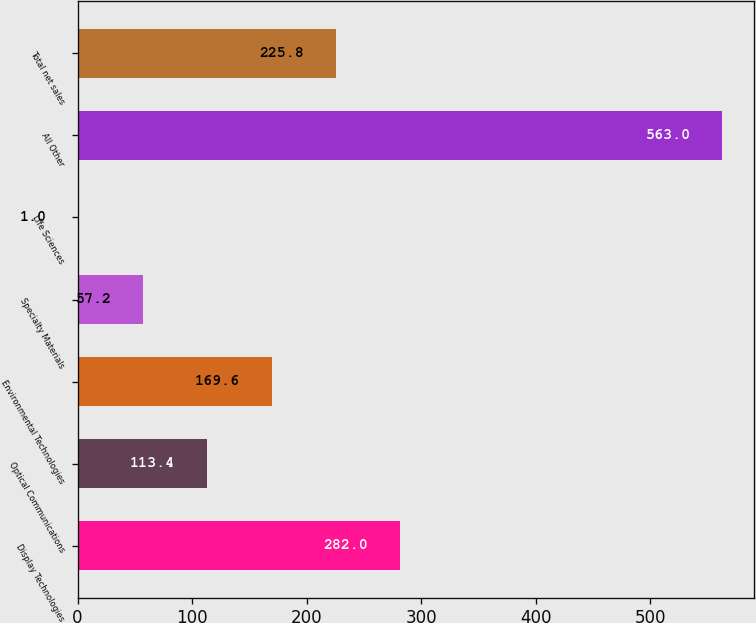Convert chart to OTSL. <chart><loc_0><loc_0><loc_500><loc_500><bar_chart><fcel>Display Technologies<fcel>Optical Communications<fcel>Environmental Technologies<fcel>Specialty Materials<fcel>Life Sciences<fcel>All Other<fcel>Total net sales<nl><fcel>282<fcel>113.4<fcel>169.6<fcel>57.2<fcel>1<fcel>563<fcel>225.8<nl></chart> 